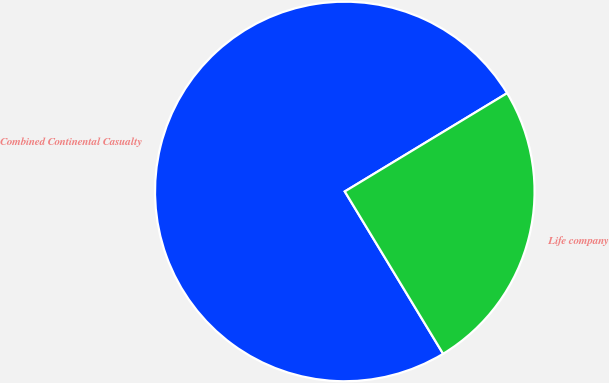Convert chart. <chart><loc_0><loc_0><loc_500><loc_500><pie_chart><fcel>Combined Continental Casualty<fcel>Life company<nl><fcel>75.0%<fcel>25.0%<nl></chart> 